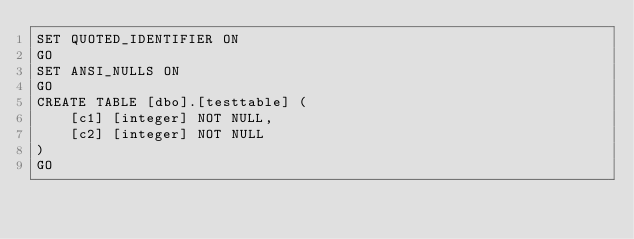Convert code to text. <code><loc_0><loc_0><loc_500><loc_500><_SQL_>SET QUOTED_IDENTIFIER ON
GO
SET ANSI_NULLS ON
GO
CREATE TABLE [dbo].[testtable] (
    [c1] [integer] NOT NULL,
    [c2] [integer] NOT NULL
)
GO
</code> 